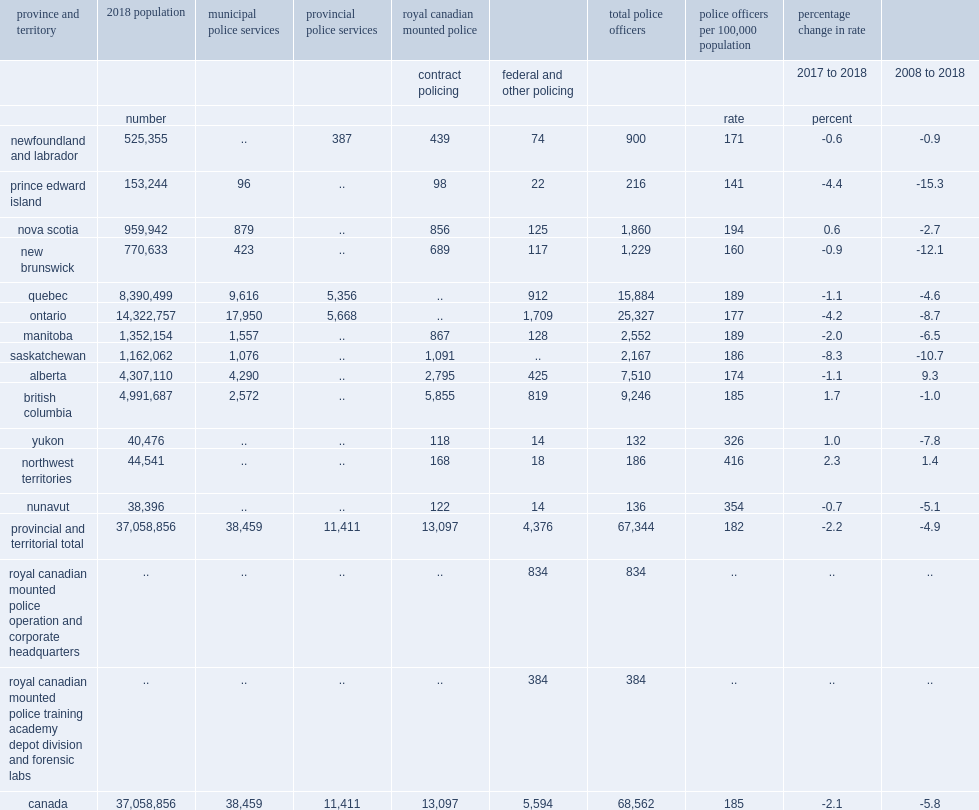Excluding officers involved in rcmp corporate duties, what is the provincial and territorial rate of police strength in 2018? 182. How many police officers were employed by stand-alone municipal police services? 38459. How many percent of all police officers in canada were employed by rcmp in contract policing? 0.191024. 